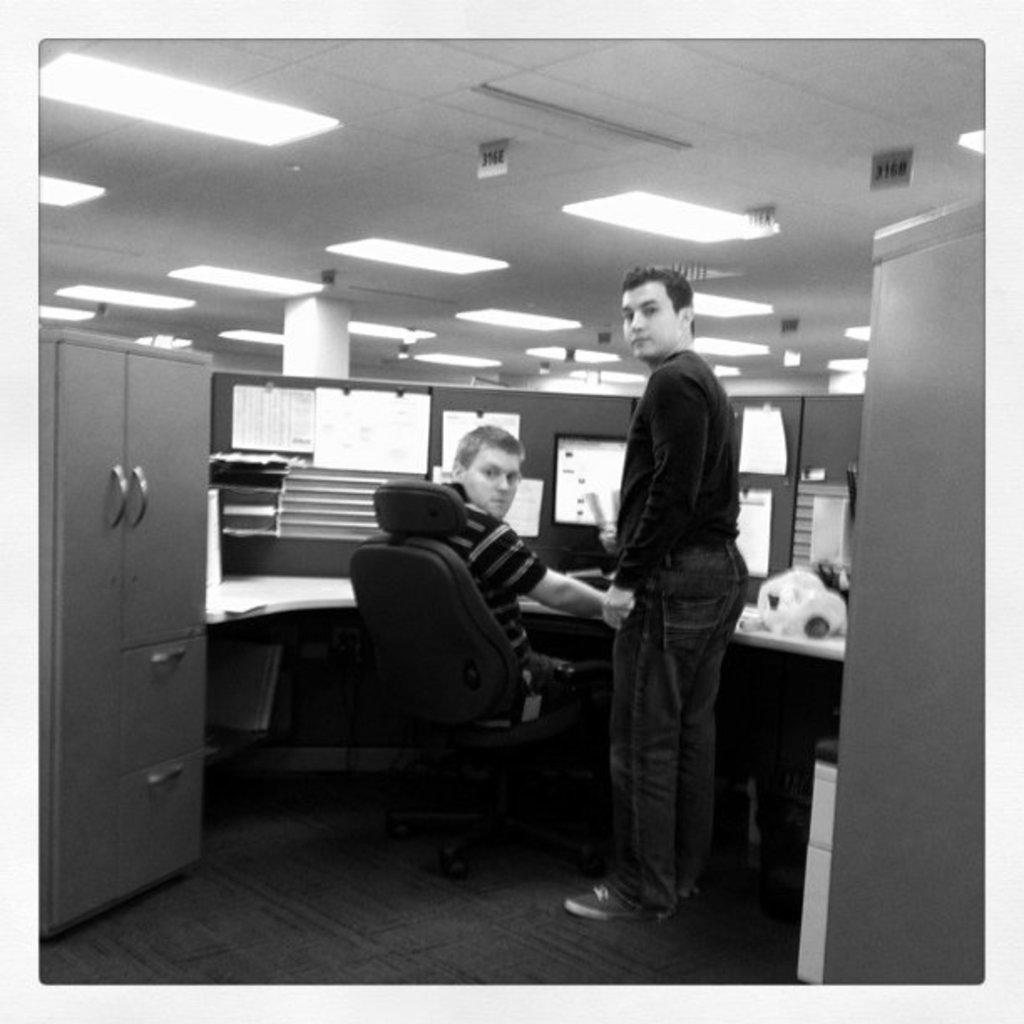Describe this image in one or two sentences. In the image a person is standing and a person is sitting on a chair. Behind them there is a table, on the table there is a screen and there are some products. At the top of the image there is roof and lights. 